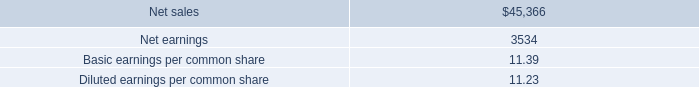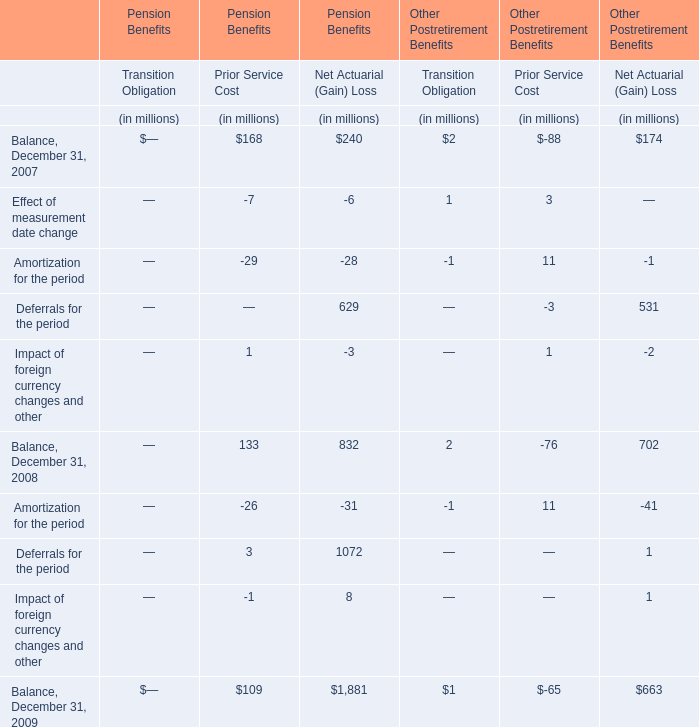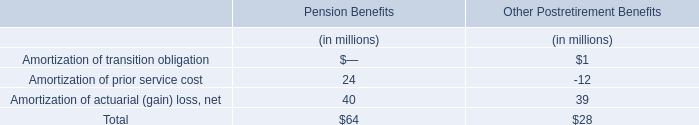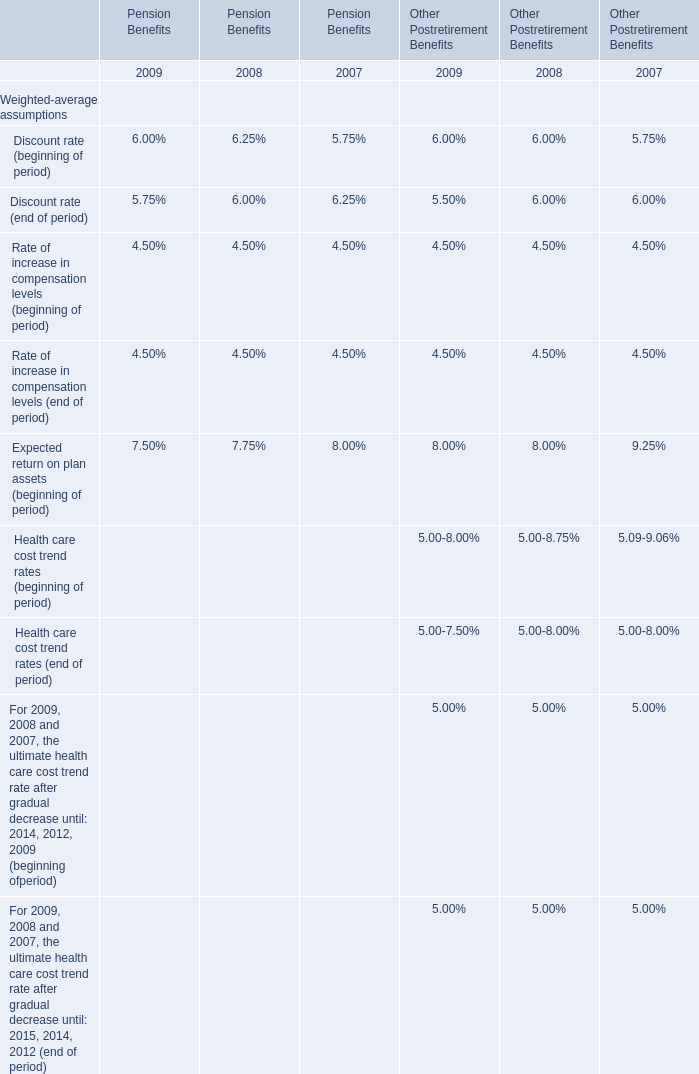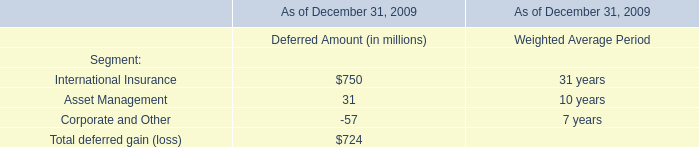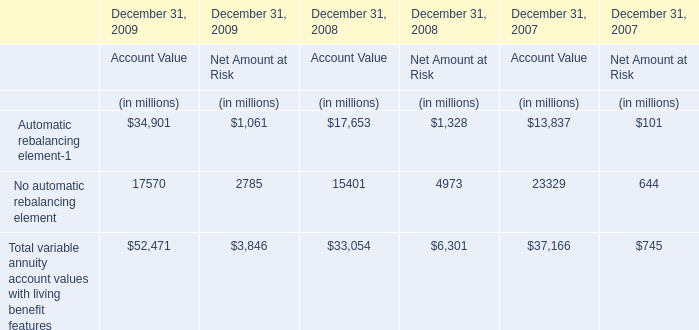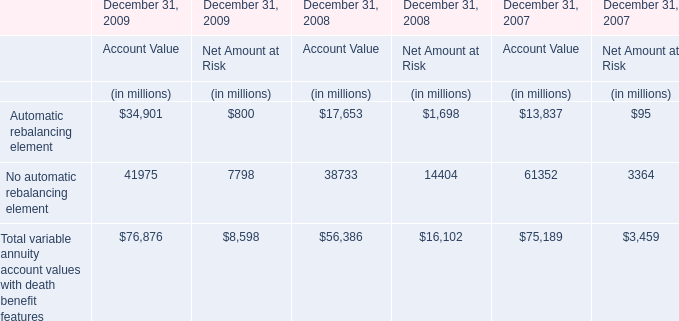what was the tax rate associated with the recognized a non-cash net gain from obtaining a controlling interest in awe 
Computations: (23 / 127)
Answer: 0.1811. 